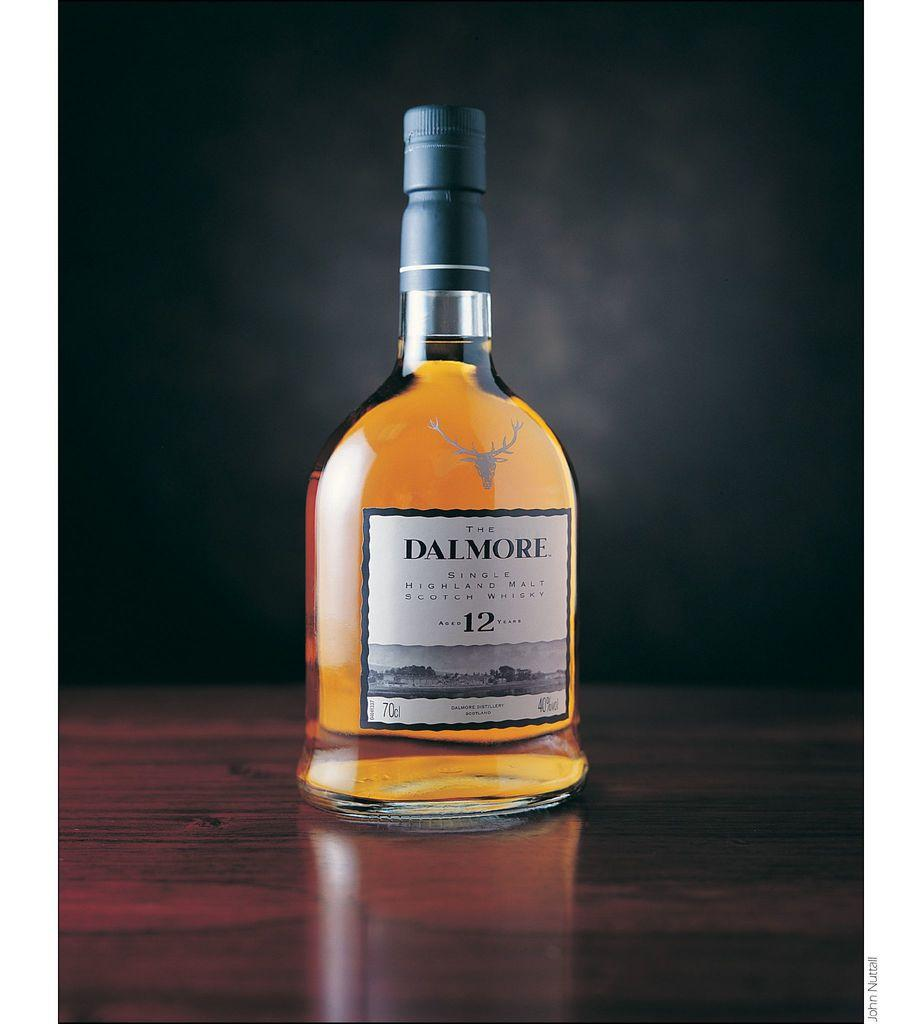Provide a one-sentence caption for the provided image. A bottle of Dalmore single highland malt scotch whiskey on a wood surface. 